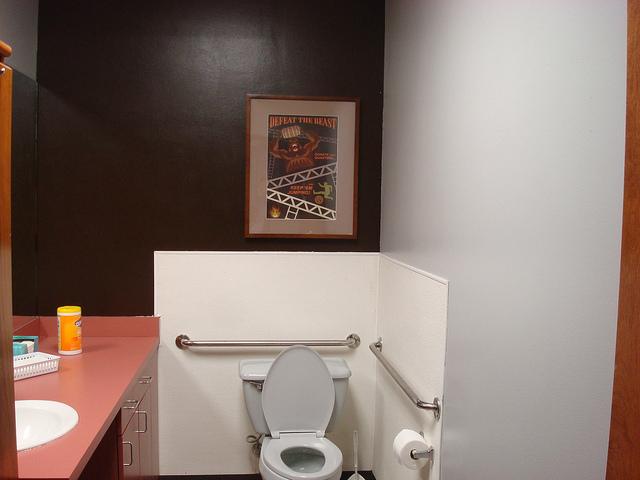Does the bathroom have an ugly color scheme?
Concise answer only. Yes. How many rolls of toilet paper are visible?
Keep it brief. 1. Is there a mirror in this room?
Short answer required. No. What brand of cleaning wipes are on the counter?
Short answer required. Clorox. Is the toilet lid up?
Give a very brief answer. Yes. What color is the sink?
Keep it brief. White. 